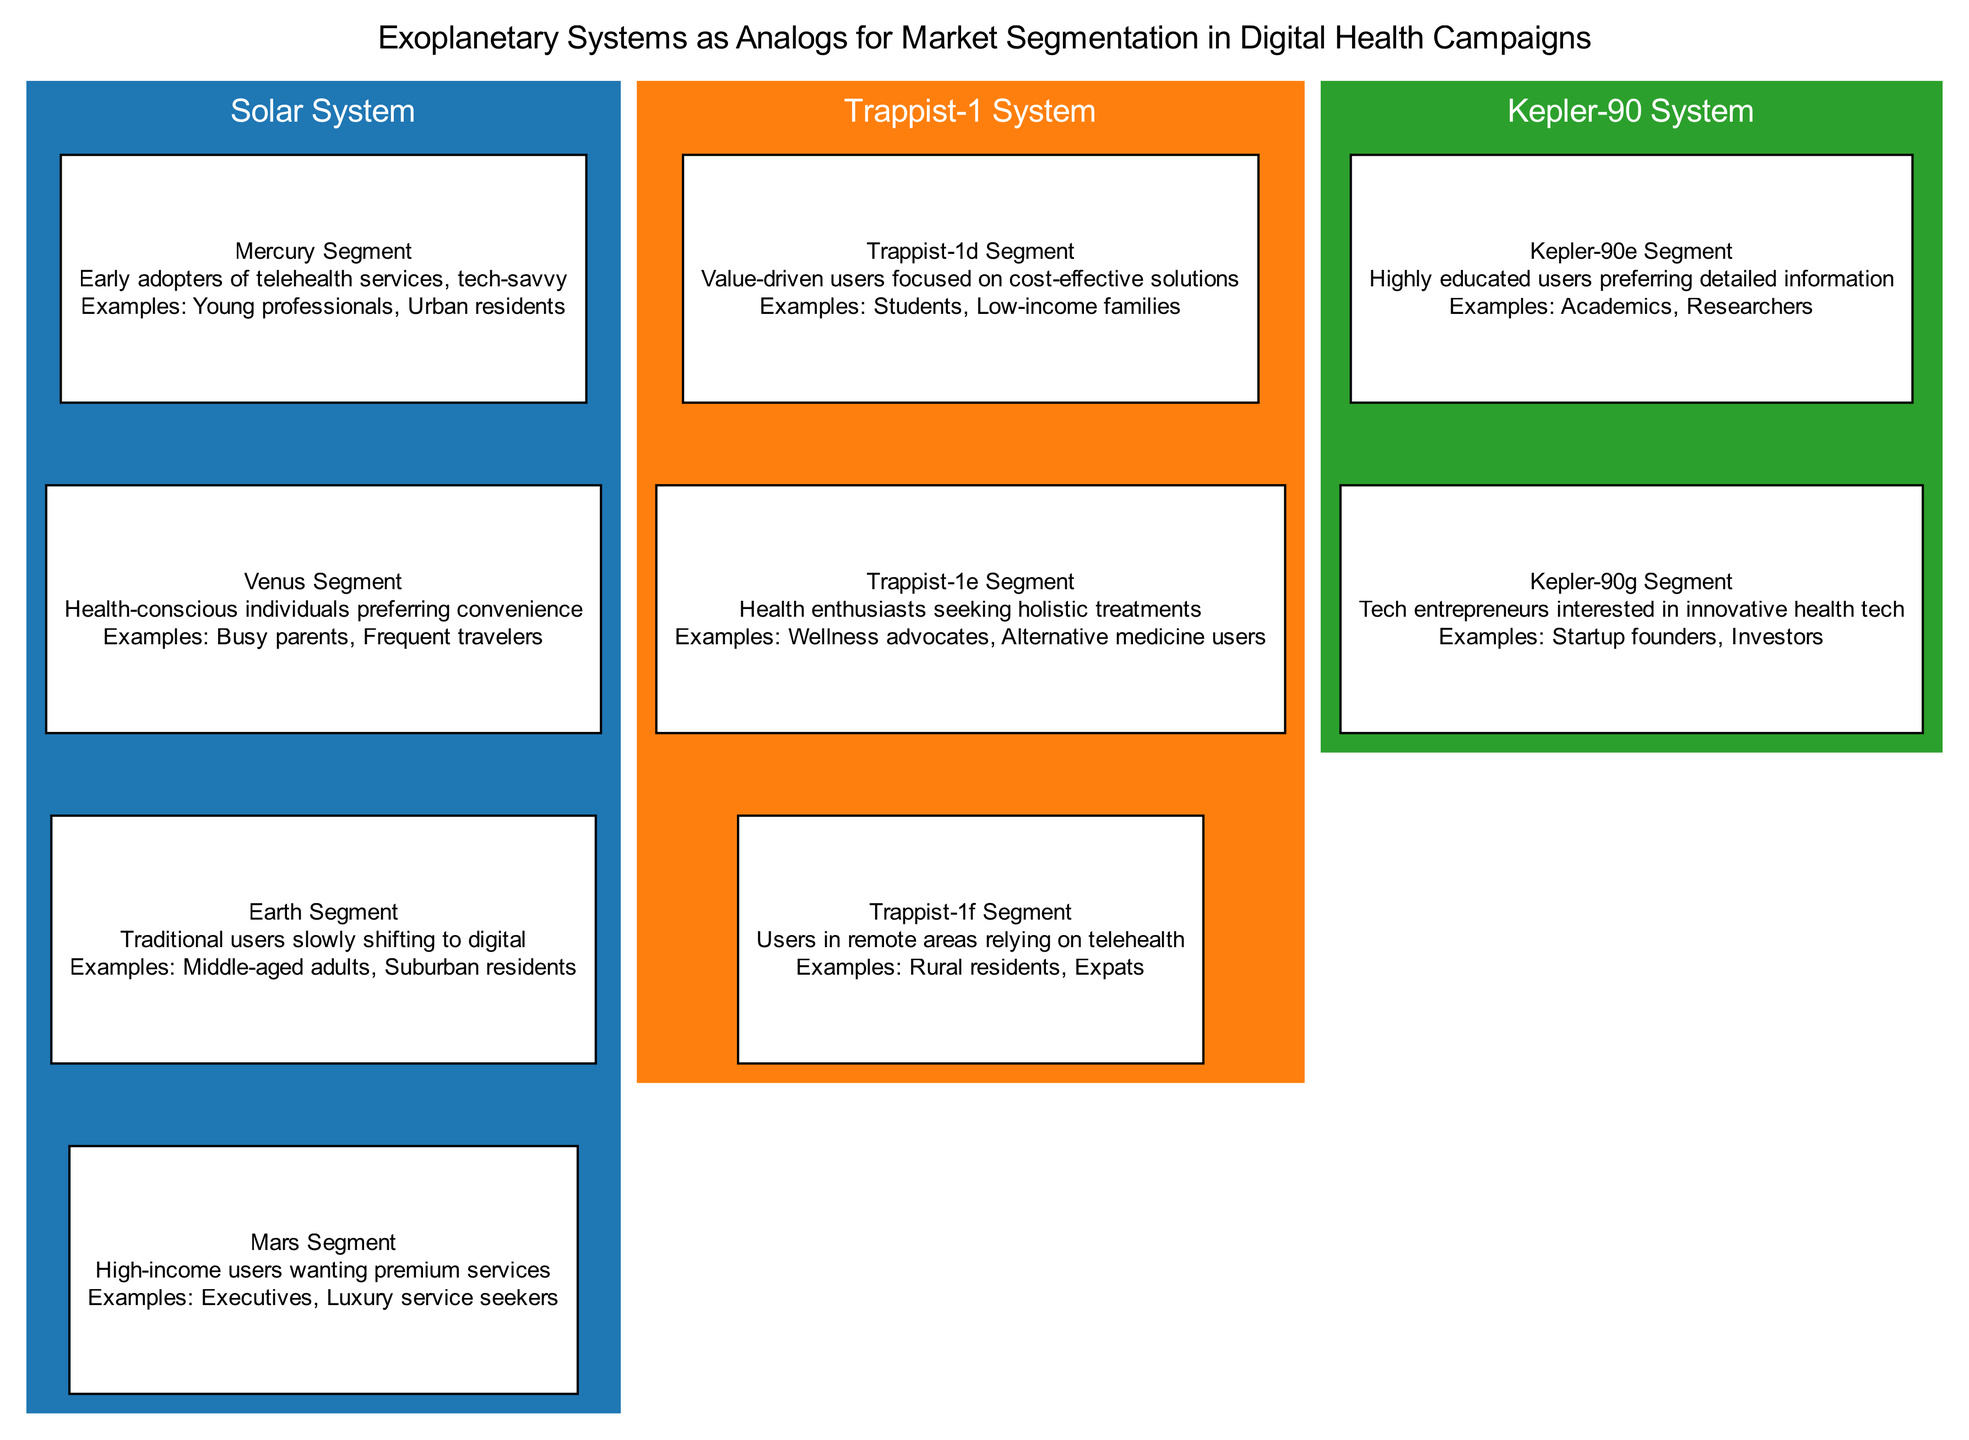what is the name of the second segment in the Solar System? The second segment in the Solar System is Venus Segment. This is derived from looking at the children of the Solar System node and identifying the second entry in the list.
Answer: Venus Segment how many segments are there in the Trappist-1 System? There are three segments in the Trappist-1 System. This can be determined by counting the children nodes listed under the Trappist-1 System node.
Answer: 3 what type of users are represented in the Mars Segment? The Mars Segment represents high-income users wanting premium services. This can be found by looking at the description provided under the Mars Segment node.
Answer: High-income users wanting premium services which segment is focused on cost-effective solutions? The segment focused on cost-effective solutions is Trappist-1d Segment. This description is included under the child nodes of the Trappist-1 System.
Answer: Trappist-1d Segment what is the relationship between the Kepler-90e Segment and Kepler-90g Segment? The relationship is that both are segments under the same Kepler-90 System, indicating they share the same parent node but represent different user preferences. This is visible as both segments are described under Kepler-90 System in the diagram.
Answer: Same parent node which segment includes examples like "Startup founders" and "Investors"? The segment that includes examples like "Startup founders" and "Investors" is the Kepler-90g Segment. This is explicitly stated in the examples of that segment in the diagram.
Answer: Kepler-90g Segment how many exoplanetary systems are mapped in this diagram? There are three exoplanetary systems mapped in the diagram: Solar System, Trappist-1 System, and Kepler-90 System. Each of these systems is represented as a parent node.
Answer: 3 which user segment is described as "Traditional users slowly shifting to digital"? The user segment described as "Traditional users slowly shifting to digital" is the Earth Segment. This description is specifically listed under the Earth Segment node in the diagram.
Answer: Earth Segment 